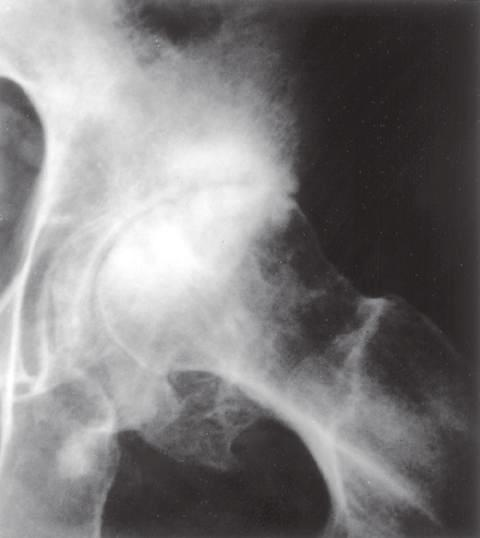s the joint space narrowed?
Answer the question using a single word or phrase. Yes 